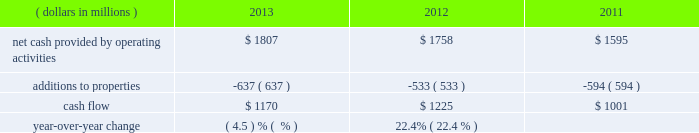General market conditions affecting trust asset performance , future discount rates based on average yields of high quality corporate bonds and our decisions regarding certain elective provisions of the we currently project that we will make total u.s .
And foreign benefit plan contributions in 2014 of approximately $ 57 million .
Actual 2014 contributions could be different from our current projections , as influenced by our decision to undertake discretionary funding of our benefit trusts versus other competing investment priorities , future changes in government requirements , trust asset performance , renewals of union contracts , or higher-than-expected health care claims cost experience .
We measure cash flow as net cash provided by operating activities reduced by expenditures for property additions .
We use this non-gaap financial measure of cash flow to focus management and investors on the amount of cash available for debt repayment , dividend distributions , acquisition opportunities , and share repurchases .
Our cash flow metric is reconciled to the most comparable gaap measure , as follows: .
Year-over-year change ( 4.5 ) % (  % ) 22.4% ( 22.4 % ) the decrease in cash flow ( as defined ) in 2013 compared to 2012 was due primarily to higher capital expenditures .
The increase in cash flow in 2012 compared to 2011 was driven by improved performance in working capital resulting from the one-time benefit derived from the pringles acquisition , as well as changes in the level of capital expenditures during the three-year period .
Investing activities our net cash used in investing activities for 2013 amounted to $ 641 million , a decrease of $ 2604 million compared with 2012 primarily attributable to the $ 2668 million acquisition of pringles in 2012 .
Capital spending in 2013 included investments in our supply chain infrastructure , and to support capacity requirements in certain markets , including pringles .
In addition , we continued the investment in our information technology infrastructure related to the reimplementation and upgrade of our sap platform .
Net cash used in investing activities of $ 3245 million in 2012 increased by $ 2658 million compared with 2011 , due to the acquisition of pringles in 2012 .
Cash paid for additions to properties as a percentage of net sales has increased to 4.3% ( 4.3 % ) in 2013 , from 3.8% ( 3.8 % ) in 2012 , which was a decrease from 4.5% ( 4.5 % ) in financing activities our net cash used by financing activities was $ 1141 million for 2013 , compared to net cash provided by financing activities of $ 1317 million for 2012 and net cash used in financing activities of $ 957 million for 2011 .
The increase in cash provided from financing activities in 2012 compared to 2013 and 2011 , was primarily due to the issuance of debt related to the acquisition of pringles .
Total debt was $ 7.4 billion at year-end 2013 and $ 7.9 billion at year-end 2012 .
In february 2013 , we issued $ 250 million of two-year floating-rate u.s .
Dollar notes , and $ 400 million of ten-year 2.75% ( 2.75 % ) u.s .
Dollar notes , resulting in aggregate net proceeds after debt discount of $ 645 million .
The proceeds from these notes were used for general corporate purposes , including , together with cash on hand , repayment of the $ 750 million aggregate principal amount of our 4.25% ( 4.25 % ) u.s .
Dollar notes due march 2013 .
In may 2012 , we issued $ 350 million of three-year 1.125% ( 1.125 % ) u.s .
Dollar notes , $ 400 million of five-year 1.75% ( 1.75 % ) u.s .
Dollar notes and $ 700 million of ten-year 3.125% ( 3.125 % ) u.s .
Dollar notes , resulting in aggregate net proceeds after debt discount of $ 1.442 billion .
The proceeds of these notes were used for general corporate purposes , including financing a portion of the acquisition of pringles .
In may 2012 , we issued cdn .
$ 300 million of two-year 2.10% ( 2.10 % ) fixed rate canadian dollar notes , using the proceeds from these notes for general corporate purposes , which included repayment of intercompany debt .
This repayment resulted in cash available to be used for a portion of the acquisition of pringles .
In december 2012 , we repaid $ 750 million five-year 5.125% ( 5.125 % ) u.s .
Dollar notes at maturity with commercial paper .
In april 2011 , we repaid $ 945 million ten-year 6.60% ( 6.60 % ) u.s .
Dollar notes at maturity with commercial paper .
In may 2011 , we issued $ 400 million of seven-year 3.25% ( 3.25 % ) fixed rate u.s .
Dollar notes , using the proceeds of $ 397 million for general corporate purposes and repayment of commercial paper .
In november 2011 , we issued $ 500 million of five-year 1.875% ( 1.875 % ) fixed rate u .
Dollar notes , using the proceeds of $ 498 million for general corporate purposes and repayment of commercial paper. .
What was the average cash flow from 2011 to 2013 in millions? 
Computations: (((1001 + (1170 + 1225)) + 3) / 2)
Answer: 1699.5. 